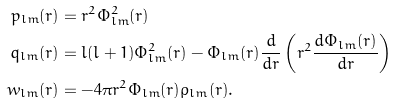<formula> <loc_0><loc_0><loc_500><loc_500>p _ { l m } ( r ) & = r ^ { 2 } \Phi _ { l m } ^ { 2 } ( r ) \\ q _ { l m } ( r ) & = l ( l + 1 ) \Phi _ { l m } ^ { 2 } ( r ) - \Phi _ { l m } ( r ) \frac { d } { d r } \left ( r ^ { 2 } \frac { d \Phi _ { l m } ( r ) } { d r } \right ) \\ w _ { l m } ( r ) & = - 4 \pi r ^ { 2 } \Phi _ { l m } ( r ) \rho _ { l m } ( r ) .</formula> 